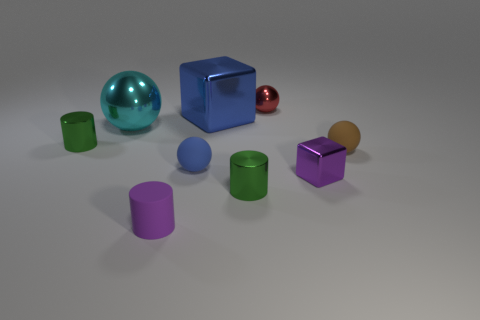What material is the purple object that is on the right side of the large metallic object on the right side of the big cyan metal sphere?
Provide a succinct answer. Metal. There is a tiny purple thing that is behind the small purple rubber cylinder; what material is it?
Keep it short and to the point. Metal. How many large cyan things are the same shape as the big blue thing?
Make the answer very short. 0. Does the large metallic sphere have the same color as the tiny shiny ball?
Your answer should be very brief. No. There is a green cylinder behind the brown rubber sphere right of the tiny object behind the large cyan sphere; what is it made of?
Offer a very short reply. Metal. There is a blue shiny block; are there any small purple metallic things behind it?
Make the answer very short. No. There is a brown matte object that is the same size as the red object; what shape is it?
Offer a very short reply. Sphere. Are the tiny purple cylinder and the tiny block made of the same material?
Provide a short and direct response. No. How many matte objects are either purple objects or blocks?
Provide a succinct answer. 1. There is a thing that is the same color as the tiny metal block; what is its shape?
Your answer should be compact. Cylinder. 